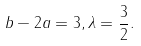Convert formula to latex. <formula><loc_0><loc_0><loc_500><loc_500>b - 2 a = 3 , \lambda = \frac { 3 } { 2 } .</formula> 